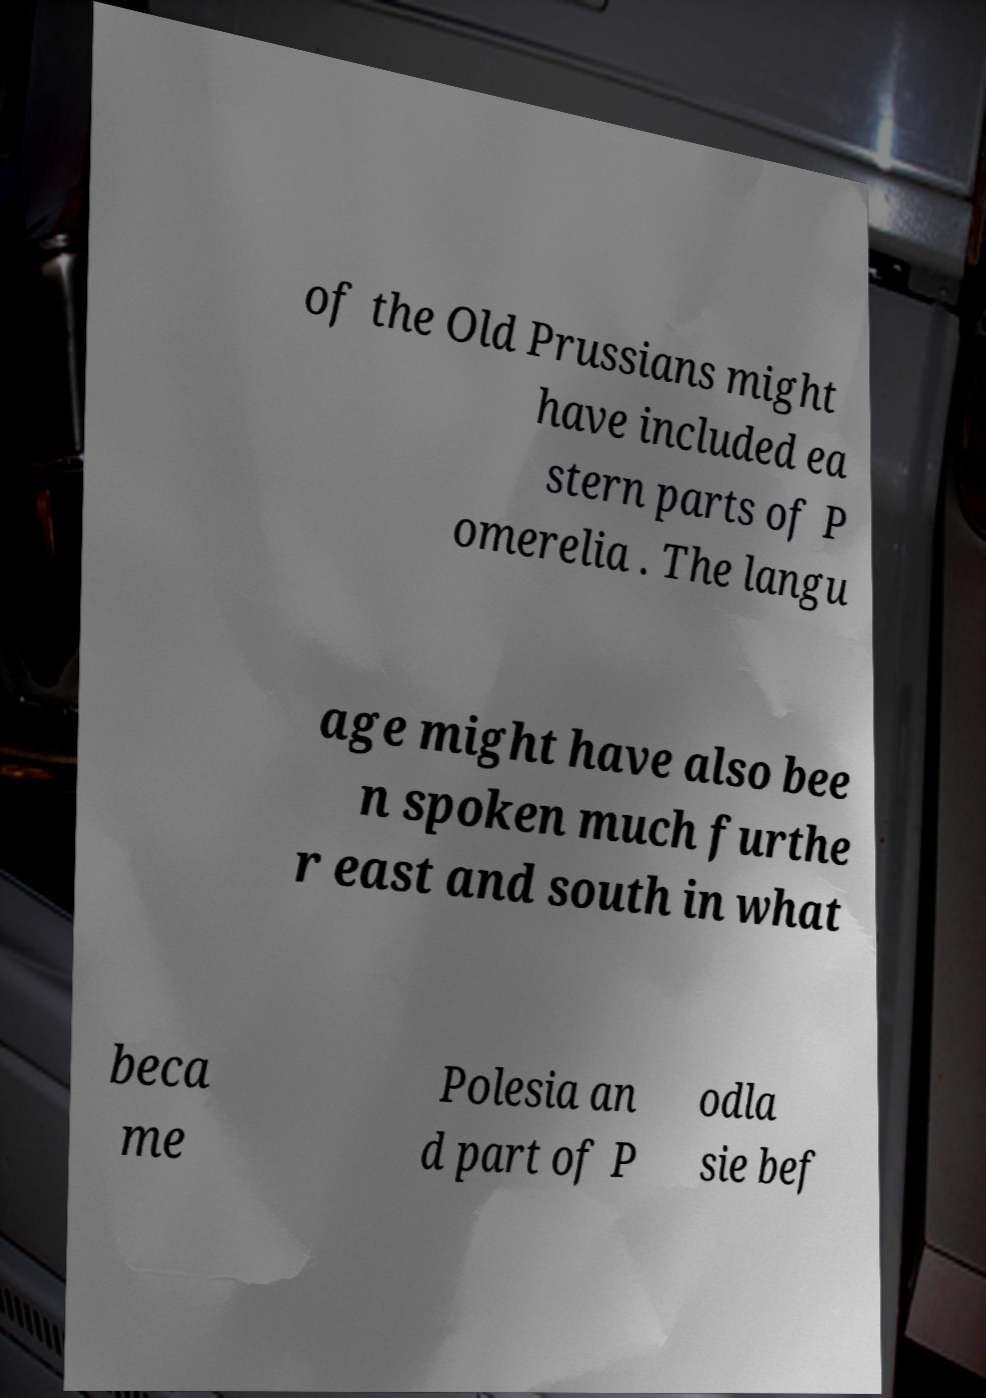Can you read and provide the text displayed in the image?This photo seems to have some interesting text. Can you extract and type it out for me? of the Old Prussians might have included ea stern parts of P omerelia . The langu age might have also bee n spoken much furthe r east and south in what beca me Polesia an d part of P odla sie bef 